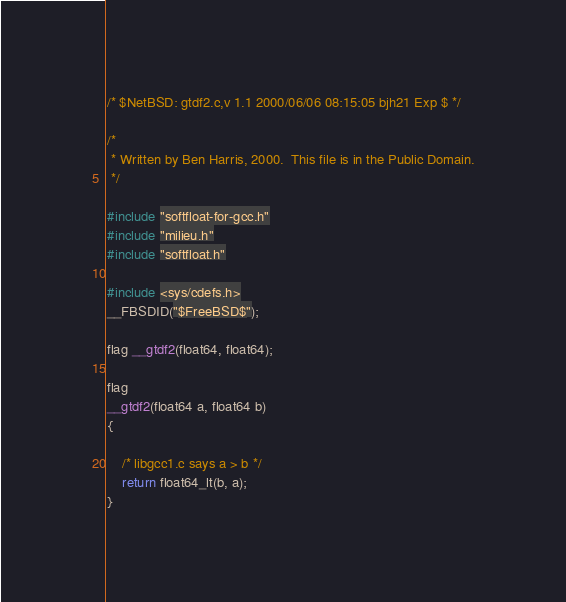<code> <loc_0><loc_0><loc_500><loc_500><_C_>/* $NetBSD: gtdf2.c,v 1.1 2000/06/06 08:15:05 bjh21 Exp $ */

/*
 * Written by Ben Harris, 2000.  This file is in the Public Domain.
 */

#include "softfloat-for-gcc.h"
#include "milieu.h"
#include "softfloat.h"

#include <sys/cdefs.h>
__FBSDID("$FreeBSD$");

flag __gtdf2(float64, float64);

flag
__gtdf2(float64 a, float64 b)
{

	/* libgcc1.c says a > b */
	return float64_lt(b, a);
}
</code> 